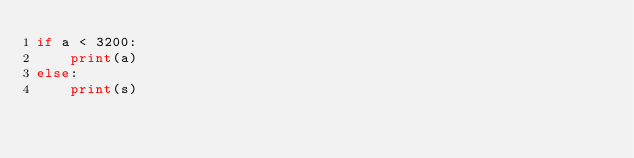<code> <loc_0><loc_0><loc_500><loc_500><_Python_>if a < 3200:
	print(a)
else:
	print(s)</code> 